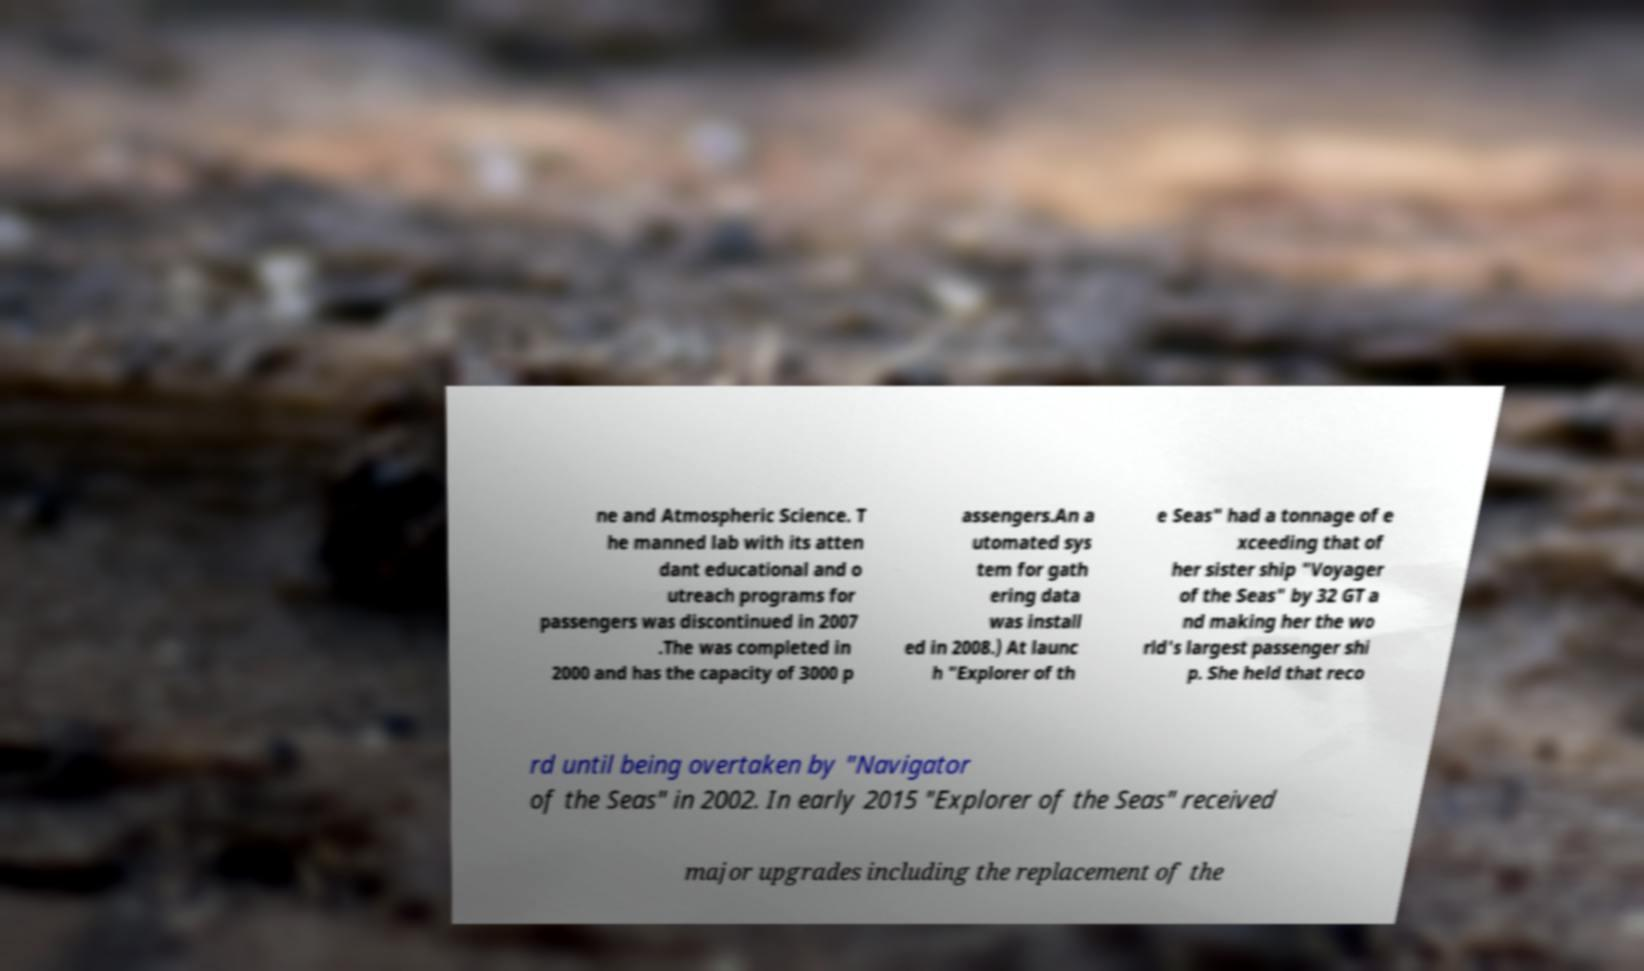Could you extract and type out the text from this image? ne and Atmospheric Science. T he manned lab with its atten dant educational and o utreach programs for passengers was discontinued in 2007 .The was completed in 2000 and has the capacity of 3000 p assengers.An a utomated sys tem for gath ering data was install ed in 2008.) At launc h "Explorer of th e Seas" had a tonnage of e xceeding that of her sister ship "Voyager of the Seas" by 32 GT a nd making her the wo rld's largest passenger shi p. She held that reco rd until being overtaken by "Navigator of the Seas" in 2002. In early 2015 "Explorer of the Seas" received major upgrades including the replacement of the 